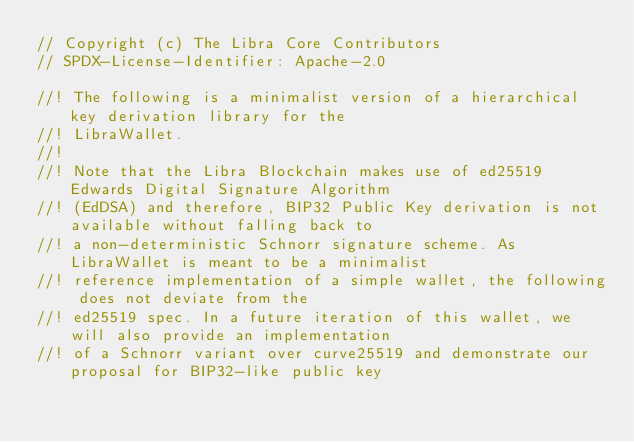Convert code to text. <code><loc_0><loc_0><loc_500><loc_500><_Rust_>// Copyright (c) The Libra Core Contributors
// SPDX-License-Identifier: Apache-2.0

//! The following is a minimalist version of a hierarchical key derivation library for the
//! LibraWallet.
//!
//! Note that the Libra Blockchain makes use of ed25519 Edwards Digital Signature Algorithm
//! (EdDSA) and therefore, BIP32 Public Key derivation is not available without falling back to
//! a non-deterministic Schnorr signature scheme. As LibraWallet is meant to be a minimalist
//! reference implementation of a simple wallet, the following does not deviate from the
//! ed25519 spec. In a future iteration of this wallet, we will also provide an implementation
//! of a Schnorr variant over curve25519 and demonstrate our proposal for BIP32-like public key</code> 